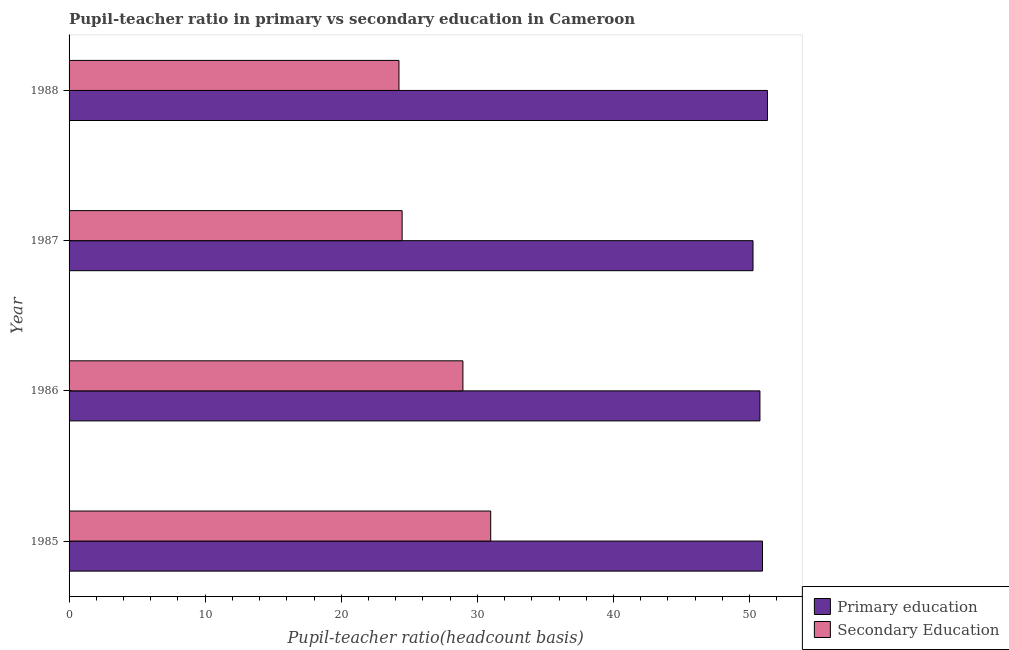How many different coloured bars are there?
Your response must be concise. 2. Are the number of bars per tick equal to the number of legend labels?
Your response must be concise. Yes. What is the label of the 4th group of bars from the top?
Provide a succinct answer. 1985. What is the pupil-teacher ratio in primary education in 1988?
Your response must be concise. 51.31. Across all years, what is the maximum pupil-teacher ratio in primary education?
Your answer should be compact. 51.31. Across all years, what is the minimum pupil teacher ratio on secondary education?
Your answer should be very brief. 24.24. In which year was the pupil teacher ratio on secondary education maximum?
Your response must be concise. 1985. In which year was the pupil teacher ratio on secondary education minimum?
Your answer should be very brief. 1988. What is the total pupil-teacher ratio in primary education in the graph?
Give a very brief answer. 203.26. What is the difference between the pupil-teacher ratio in primary education in 1986 and that in 1988?
Make the answer very short. -0.55. What is the difference between the pupil-teacher ratio in primary education in 1987 and the pupil teacher ratio on secondary education in 1988?
Your answer should be compact. 26.01. What is the average pupil teacher ratio on secondary education per year?
Provide a succinct answer. 27.16. In the year 1988, what is the difference between the pupil teacher ratio on secondary education and pupil-teacher ratio in primary education?
Offer a very short reply. -27.07. In how many years, is the pupil teacher ratio on secondary education greater than 46 ?
Ensure brevity in your answer.  0. What is the ratio of the pupil teacher ratio on secondary education in 1985 to that in 1987?
Keep it short and to the point. 1.27. What is the difference between the highest and the second highest pupil-teacher ratio in primary education?
Your response must be concise. 0.36. What is the difference between the highest and the lowest pupil teacher ratio on secondary education?
Offer a very short reply. 6.74. In how many years, is the pupil teacher ratio on secondary education greater than the average pupil teacher ratio on secondary education taken over all years?
Your answer should be very brief. 2. Is the sum of the pupil-teacher ratio in primary education in 1985 and 1988 greater than the maximum pupil teacher ratio on secondary education across all years?
Ensure brevity in your answer.  Yes. What does the 2nd bar from the bottom in 1988 represents?
Provide a succinct answer. Secondary Education. Are all the bars in the graph horizontal?
Provide a succinct answer. Yes. How many legend labels are there?
Make the answer very short. 2. What is the title of the graph?
Provide a short and direct response. Pupil-teacher ratio in primary vs secondary education in Cameroon. What is the label or title of the X-axis?
Offer a terse response. Pupil-teacher ratio(headcount basis). What is the Pupil-teacher ratio(headcount basis) in Primary education in 1985?
Your response must be concise. 50.95. What is the Pupil-teacher ratio(headcount basis) of Secondary Education in 1985?
Your answer should be compact. 30.98. What is the Pupil-teacher ratio(headcount basis) of Primary education in 1986?
Make the answer very short. 50.76. What is the Pupil-teacher ratio(headcount basis) of Secondary Education in 1986?
Keep it short and to the point. 28.94. What is the Pupil-teacher ratio(headcount basis) of Primary education in 1987?
Provide a short and direct response. 50.25. What is the Pupil-teacher ratio(headcount basis) of Secondary Education in 1987?
Provide a succinct answer. 24.47. What is the Pupil-teacher ratio(headcount basis) of Primary education in 1988?
Provide a succinct answer. 51.31. What is the Pupil-teacher ratio(headcount basis) in Secondary Education in 1988?
Give a very brief answer. 24.24. Across all years, what is the maximum Pupil-teacher ratio(headcount basis) in Primary education?
Offer a terse response. 51.31. Across all years, what is the maximum Pupil-teacher ratio(headcount basis) of Secondary Education?
Offer a terse response. 30.98. Across all years, what is the minimum Pupil-teacher ratio(headcount basis) in Primary education?
Make the answer very short. 50.25. Across all years, what is the minimum Pupil-teacher ratio(headcount basis) in Secondary Education?
Offer a terse response. 24.24. What is the total Pupil-teacher ratio(headcount basis) of Primary education in the graph?
Offer a terse response. 203.26. What is the total Pupil-teacher ratio(headcount basis) in Secondary Education in the graph?
Your answer should be very brief. 108.62. What is the difference between the Pupil-teacher ratio(headcount basis) of Primary education in 1985 and that in 1986?
Ensure brevity in your answer.  0.19. What is the difference between the Pupil-teacher ratio(headcount basis) in Secondary Education in 1985 and that in 1986?
Give a very brief answer. 2.04. What is the difference between the Pupil-teacher ratio(headcount basis) of Primary education in 1985 and that in 1987?
Provide a succinct answer. 0.7. What is the difference between the Pupil-teacher ratio(headcount basis) in Secondary Education in 1985 and that in 1987?
Make the answer very short. 6.51. What is the difference between the Pupil-teacher ratio(headcount basis) of Primary education in 1985 and that in 1988?
Offer a very short reply. -0.36. What is the difference between the Pupil-teacher ratio(headcount basis) in Secondary Education in 1985 and that in 1988?
Ensure brevity in your answer.  6.74. What is the difference between the Pupil-teacher ratio(headcount basis) of Primary education in 1986 and that in 1987?
Your response must be concise. 0.51. What is the difference between the Pupil-teacher ratio(headcount basis) in Secondary Education in 1986 and that in 1987?
Ensure brevity in your answer.  4.47. What is the difference between the Pupil-teacher ratio(headcount basis) of Primary education in 1986 and that in 1988?
Offer a very short reply. -0.55. What is the difference between the Pupil-teacher ratio(headcount basis) of Secondary Education in 1986 and that in 1988?
Provide a succinct answer. 4.7. What is the difference between the Pupil-teacher ratio(headcount basis) of Primary education in 1987 and that in 1988?
Make the answer very short. -1.06. What is the difference between the Pupil-teacher ratio(headcount basis) in Secondary Education in 1987 and that in 1988?
Offer a very short reply. 0.23. What is the difference between the Pupil-teacher ratio(headcount basis) of Primary education in 1985 and the Pupil-teacher ratio(headcount basis) of Secondary Education in 1986?
Ensure brevity in your answer.  22.01. What is the difference between the Pupil-teacher ratio(headcount basis) in Primary education in 1985 and the Pupil-teacher ratio(headcount basis) in Secondary Education in 1987?
Your answer should be compact. 26.48. What is the difference between the Pupil-teacher ratio(headcount basis) in Primary education in 1985 and the Pupil-teacher ratio(headcount basis) in Secondary Education in 1988?
Keep it short and to the point. 26.71. What is the difference between the Pupil-teacher ratio(headcount basis) of Primary education in 1986 and the Pupil-teacher ratio(headcount basis) of Secondary Education in 1987?
Keep it short and to the point. 26.29. What is the difference between the Pupil-teacher ratio(headcount basis) of Primary education in 1986 and the Pupil-teacher ratio(headcount basis) of Secondary Education in 1988?
Your answer should be compact. 26.52. What is the difference between the Pupil-teacher ratio(headcount basis) of Primary education in 1987 and the Pupil-teacher ratio(headcount basis) of Secondary Education in 1988?
Offer a very short reply. 26.01. What is the average Pupil-teacher ratio(headcount basis) in Primary education per year?
Offer a terse response. 50.81. What is the average Pupil-teacher ratio(headcount basis) in Secondary Education per year?
Provide a short and direct response. 27.15. In the year 1985, what is the difference between the Pupil-teacher ratio(headcount basis) of Primary education and Pupil-teacher ratio(headcount basis) of Secondary Education?
Provide a succinct answer. 19.97. In the year 1986, what is the difference between the Pupil-teacher ratio(headcount basis) of Primary education and Pupil-teacher ratio(headcount basis) of Secondary Education?
Your answer should be compact. 21.82. In the year 1987, what is the difference between the Pupil-teacher ratio(headcount basis) in Primary education and Pupil-teacher ratio(headcount basis) in Secondary Education?
Keep it short and to the point. 25.78. In the year 1988, what is the difference between the Pupil-teacher ratio(headcount basis) of Primary education and Pupil-teacher ratio(headcount basis) of Secondary Education?
Provide a succinct answer. 27.07. What is the ratio of the Pupil-teacher ratio(headcount basis) of Secondary Education in 1985 to that in 1986?
Provide a succinct answer. 1.07. What is the ratio of the Pupil-teacher ratio(headcount basis) in Primary education in 1985 to that in 1987?
Keep it short and to the point. 1.01. What is the ratio of the Pupil-teacher ratio(headcount basis) of Secondary Education in 1985 to that in 1987?
Give a very brief answer. 1.27. What is the ratio of the Pupil-teacher ratio(headcount basis) in Secondary Education in 1985 to that in 1988?
Your response must be concise. 1.28. What is the ratio of the Pupil-teacher ratio(headcount basis) in Secondary Education in 1986 to that in 1987?
Offer a terse response. 1.18. What is the ratio of the Pupil-teacher ratio(headcount basis) in Secondary Education in 1986 to that in 1988?
Offer a terse response. 1.19. What is the ratio of the Pupil-teacher ratio(headcount basis) in Primary education in 1987 to that in 1988?
Your response must be concise. 0.98. What is the ratio of the Pupil-teacher ratio(headcount basis) in Secondary Education in 1987 to that in 1988?
Keep it short and to the point. 1.01. What is the difference between the highest and the second highest Pupil-teacher ratio(headcount basis) in Primary education?
Make the answer very short. 0.36. What is the difference between the highest and the second highest Pupil-teacher ratio(headcount basis) in Secondary Education?
Your answer should be very brief. 2.04. What is the difference between the highest and the lowest Pupil-teacher ratio(headcount basis) of Primary education?
Keep it short and to the point. 1.06. What is the difference between the highest and the lowest Pupil-teacher ratio(headcount basis) in Secondary Education?
Ensure brevity in your answer.  6.74. 